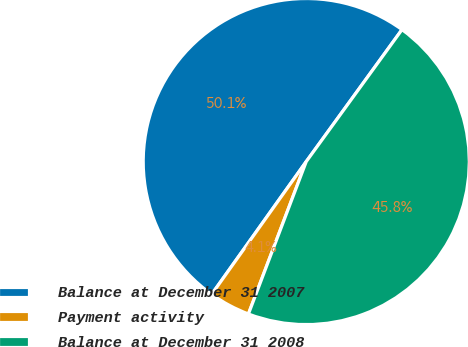<chart> <loc_0><loc_0><loc_500><loc_500><pie_chart><fcel>Balance at December 31 2007<fcel>Payment activity<fcel>Balance at December 31 2008<nl><fcel>50.14%<fcel>4.08%<fcel>45.78%<nl></chart> 